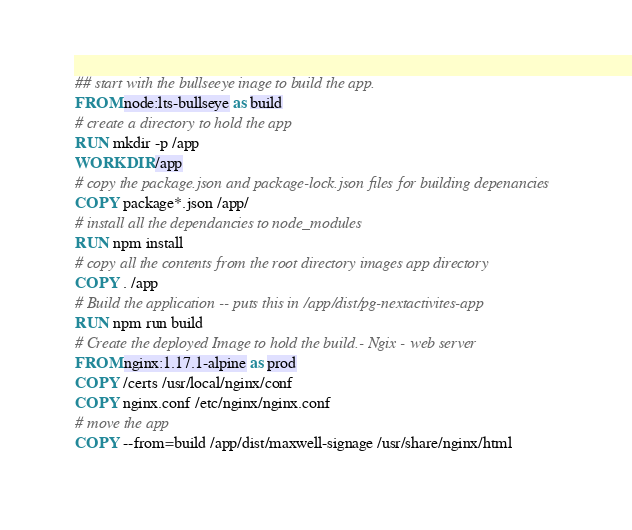Convert code to text. <code><loc_0><loc_0><loc_500><loc_500><_Dockerfile_>## start with the bullseeye inage to build the app.
FROM node:lts-bullseye as build
# create a directory to hold the app
RUN mkdir -p /app
WORKDIR /app
# copy the package.json and package-lock.json files for building depenancies
COPY package*.json /app/
# install all the dependancies to node_modules
RUN npm install
# copy all the contents from the root directory images app directory
COPY . /app
# Build the application -- puts this in /app/dist/pg-nextactivites-app
RUN npm run build
# Create the deployed Image to hold the build.- Ngix - web server
FROM nginx:1.17.1-alpine as prod
COPY /certs /usr/local/nginx/conf
COPY nginx.conf /etc/nginx/nginx.conf
# move the app
COPY --from=build /app/dist/maxwell-signage /usr/share/nginx/html</code> 